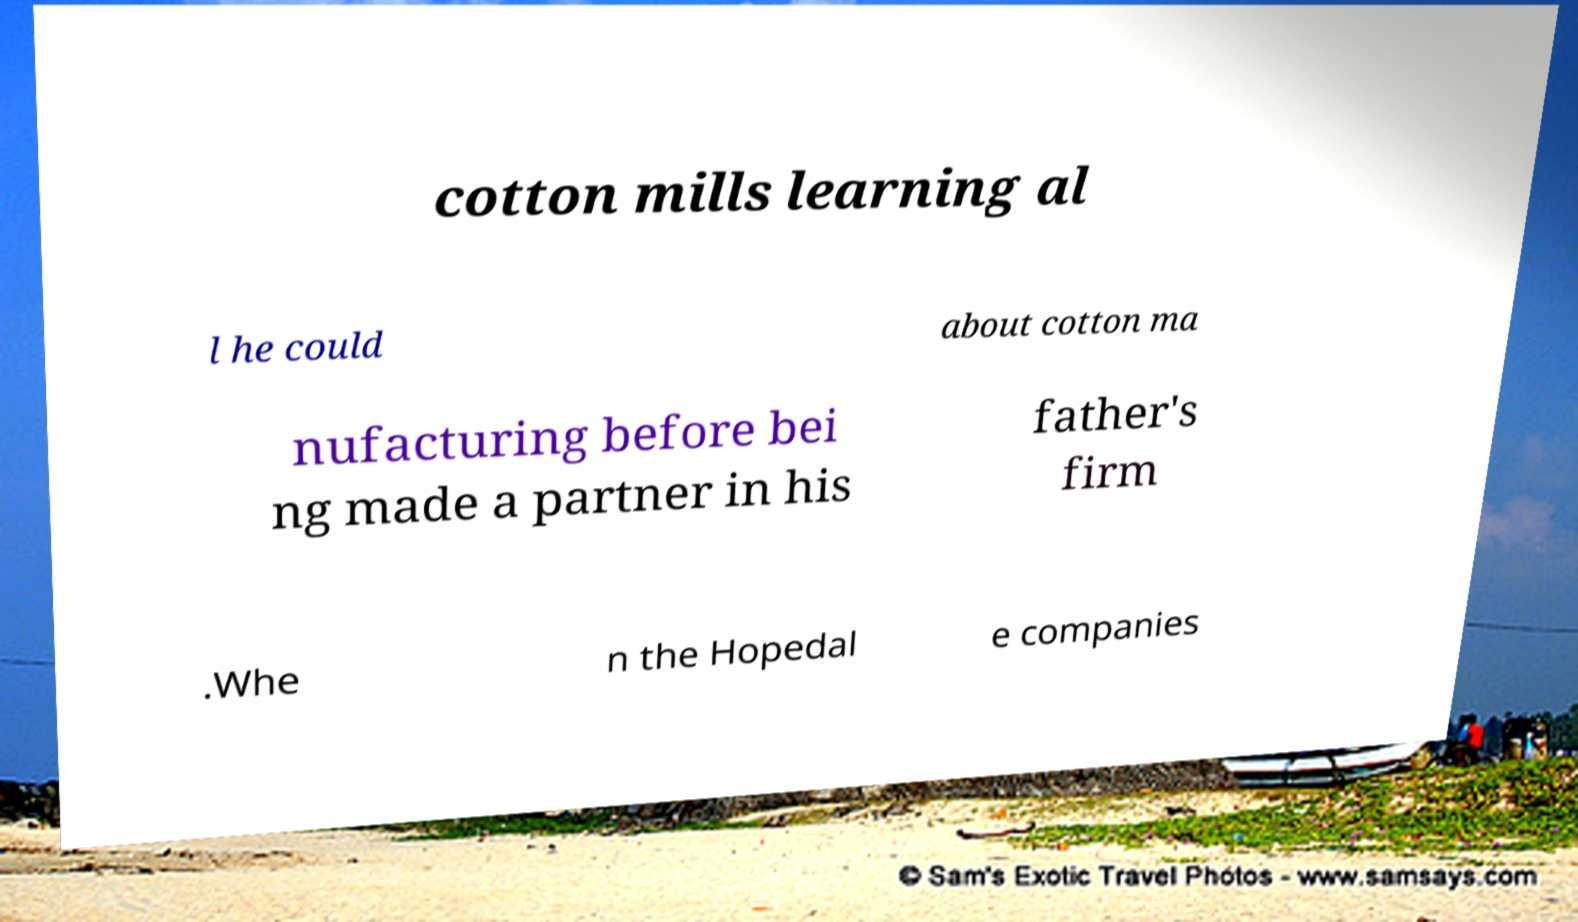Can you accurately transcribe the text from the provided image for me? cotton mills learning al l he could about cotton ma nufacturing before bei ng made a partner in his father's firm .Whe n the Hopedal e companies 